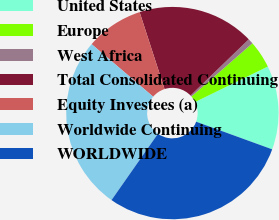Convert chart to OTSL. <chart><loc_0><loc_0><loc_500><loc_500><pie_chart><fcel>United States<fcel>Europe<fcel>West Africa<fcel>Total Consolidated Continuing<fcel>Equity Investees (a)<fcel>Worldwide Continuing<fcel>WORLDWIDE<nl><fcel>12.77%<fcel>4.19%<fcel>0.81%<fcel>17.77%<fcel>8.76%<fcel>26.53%<fcel>29.17%<nl></chart> 